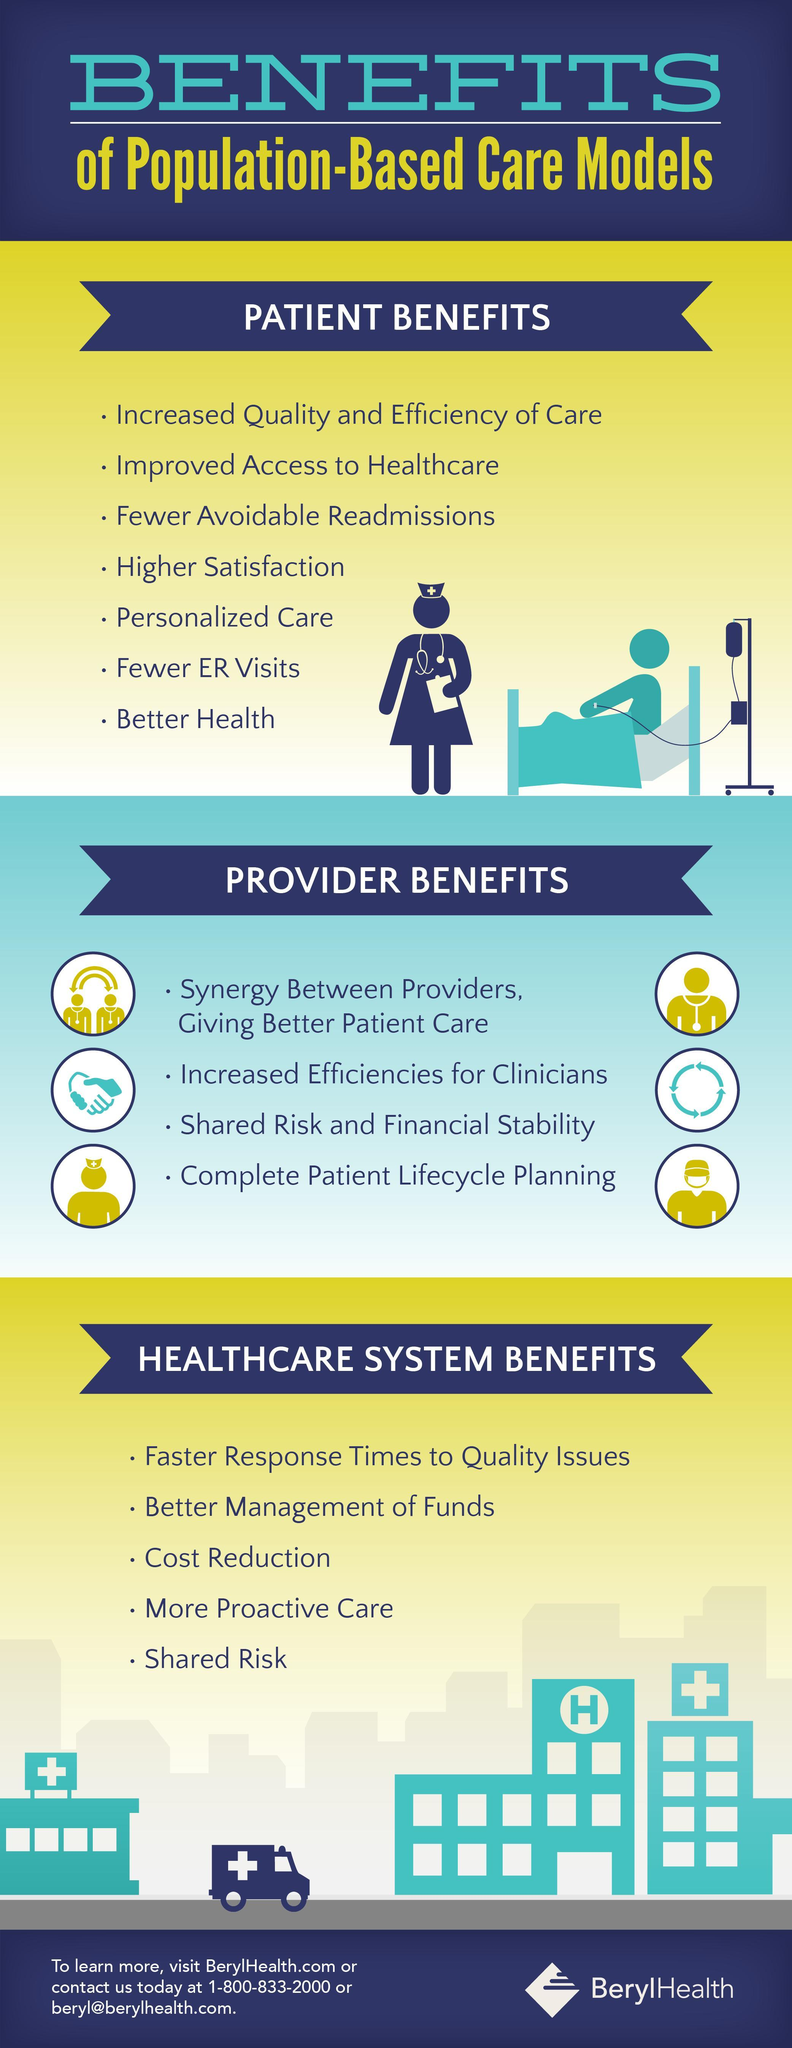How many points under the heading "Patient Benefits"?
Answer the question with a short phrase. 7 How many Healthcare system benefits? 5 How many points under the heading "Provider Benefits"? 4 